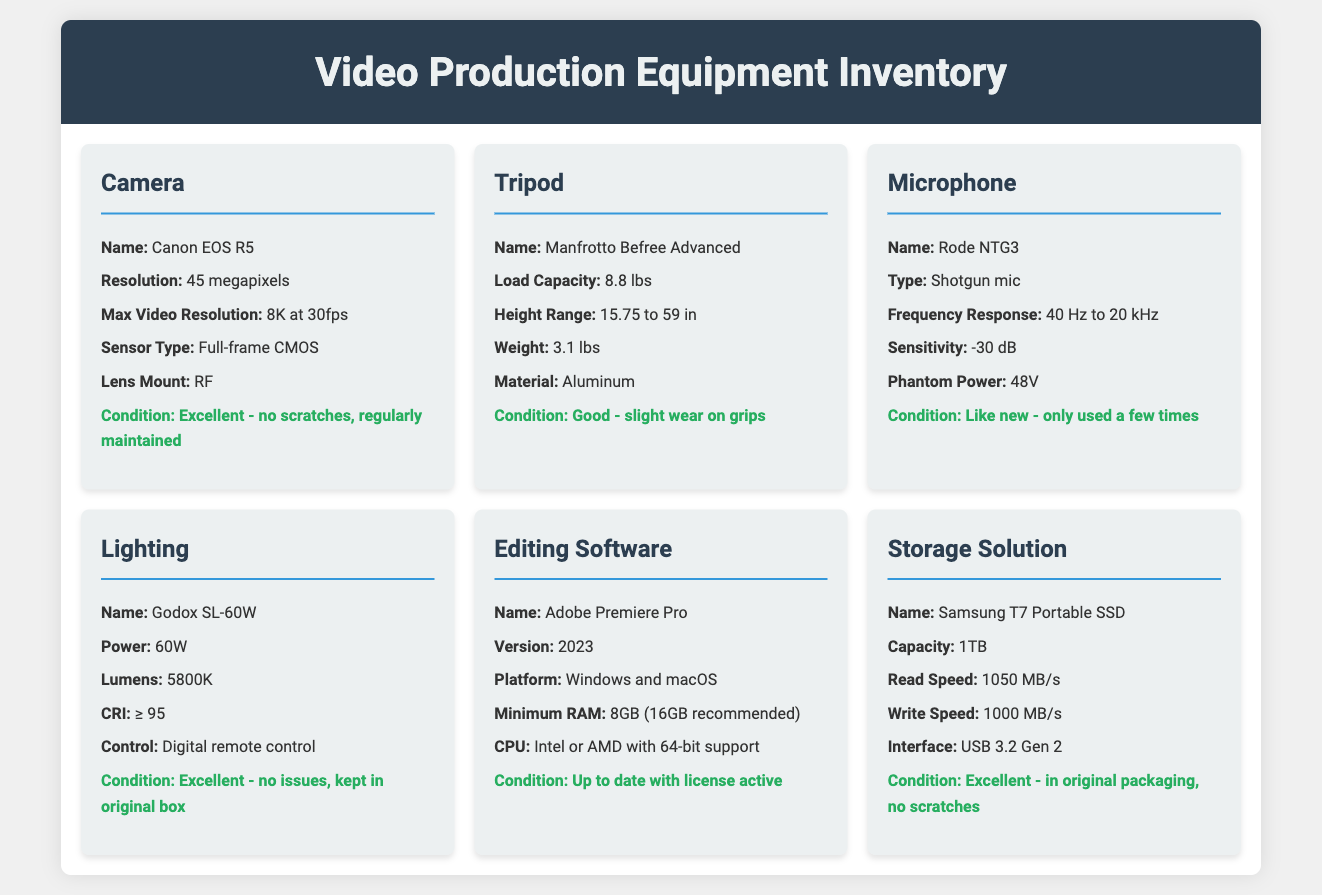What is the resolution of the camera? The camera, Canon EOS R5, has a resolution of 45 megapixels.
Answer: 45 megapixels What is the weight of the tripod? The tripod, Manfrotto Befree Advanced, weighs 3.1 lbs.
Answer: 3.1 lbs What is the frequency response of the microphone? The Rode NTG3 microphone has a frequency response of 40 Hz to 20 kHz.
Answer: 40 Hz to 20 kHz How much power does the lighting equipment consume? The Godox SL-60W has a power of 60W.
Answer: 60W What is the condition of the editing software? The Adobe Premiere Pro is described as up to date with an active license.
Answer: Up to date with license active What is the maximum write speed of the Samsung T7 Portable SSD? The Samsung T7 Portable SSD has a write speed of 1000 MB/s.
Answer: 1000 MB/s Which camera lens mount does the Canon EOS R5 use? The Canon EOS R5 uses the RF lens mount.
Answer: RF What material is the tripod made of? The Manfrotto Befree Advanced tripod is made of aluminum.
Answer: Aluminum How many items are listed in the inventory? There are six items listed in the equipment inventory.
Answer: Six items 